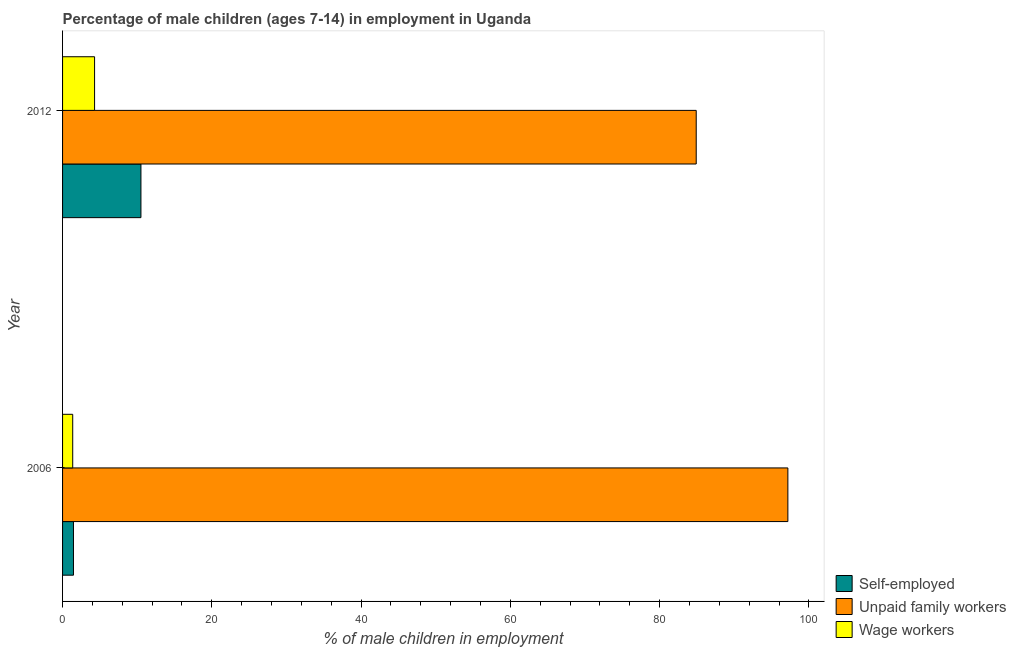Are the number of bars on each tick of the Y-axis equal?
Your answer should be very brief. Yes. What is the label of the 1st group of bars from the top?
Your response must be concise. 2012. What is the percentage of self employed children in 2012?
Your response must be concise. 10.5. Across all years, what is the maximum percentage of children employed as unpaid family workers?
Ensure brevity in your answer.  97.18. Across all years, what is the minimum percentage of self employed children?
Offer a terse response. 1.46. What is the total percentage of children employed as wage workers in the graph?
Make the answer very short. 5.65. What is the difference between the percentage of children employed as unpaid family workers in 2006 and that in 2012?
Offer a very short reply. 12.28. What is the difference between the percentage of self employed children in 2006 and the percentage of children employed as wage workers in 2012?
Give a very brief answer. -2.83. What is the average percentage of children employed as unpaid family workers per year?
Your answer should be compact. 91.04. In the year 2006, what is the difference between the percentage of children employed as wage workers and percentage of children employed as unpaid family workers?
Your response must be concise. -95.82. What is the ratio of the percentage of children employed as unpaid family workers in 2006 to that in 2012?
Provide a succinct answer. 1.15. What does the 1st bar from the top in 2006 represents?
Ensure brevity in your answer.  Wage workers. What does the 3rd bar from the bottom in 2006 represents?
Offer a very short reply. Wage workers. Is it the case that in every year, the sum of the percentage of self employed children and percentage of children employed as unpaid family workers is greater than the percentage of children employed as wage workers?
Provide a short and direct response. Yes. How many bars are there?
Offer a terse response. 6. Are all the bars in the graph horizontal?
Give a very brief answer. Yes. What is the difference between two consecutive major ticks on the X-axis?
Your answer should be very brief. 20. Does the graph contain any zero values?
Your answer should be compact. No. Where does the legend appear in the graph?
Ensure brevity in your answer.  Bottom right. How many legend labels are there?
Make the answer very short. 3. What is the title of the graph?
Ensure brevity in your answer.  Percentage of male children (ages 7-14) in employment in Uganda. Does "Negligence towards kids" appear as one of the legend labels in the graph?
Your answer should be compact. No. What is the label or title of the X-axis?
Give a very brief answer. % of male children in employment. What is the % of male children in employment of Self-employed in 2006?
Provide a succinct answer. 1.46. What is the % of male children in employment in Unpaid family workers in 2006?
Offer a terse response. 97.18. What is the % of male children in employment of Wage workers in 2006?
Provide a short and direct response. 1.36. What is the % of male children in employment of Unpaid family workers in 2012?
Offer a terse response. 84.9. What is the % of male children in employment of Wage workers in 2012?
Your answer should be very brief. 4.29. Across all years, what is the maximum % of male children in employment in Unpaid family workers?
Offer a very short reply. 97.18. Across all years, what is the maximum % of male children in employment of Wage workers?
Provide a succinct answer. 4.29. Across all years, what is the minimum % of male children in employment in Self-employed?
Your answer should be compact. 1.46. Across all years, what is the minimum % of male children in employment in Unpaid family workers?
Give a very brief answer. 84.9. Across all years, what is the minimum % of male children in employment in Wage workers?
Provide a short and direct response. 1.36. What is the total % of male children in employment in Self-employed in the graph?
Your answer should be very brief. 11.96. What is the total % of male children in employment of Unpaid family workers in the graph?
Keep it short and to the point. 182.08. What is the total % of male children in employment in Wage workers in the graph?
Keep it short and to the point. 5.65. What is the difference between the % of male children in employment of Self-employed in 2006 and that in 2012?
Give a very brief answer. -9.04. What is the difference between the % of male children in employment in Unpaid family workers in 2006 and that in 2012?
Offer a terse response. 12.28. What is the difference between the % of male children in employment of Wage workers in 2006 and that in 2012?
Your answer should be compact. -2.93. What is the difference between the % of male children in employment of Self-employed in 2006 and the % of male children in employment of Unpaid family workers in 2012?
Keep it short and to the point. -83.44. What is the difference between the % of male children in employment of Self-employed in 2006 and the % of male children in employment of Wage workers in 2012?
Keep it short and to the point. -2.83. What is the difference between the % of male children in employment of Unpaid family workers in 2006 and the % of male children in employment of Wage workers in 2012?
Ensure brevity in your answer.  92.89. What is the average % of male children in employment in Self-employed per year?
Provide a short and direct response. 5.98. What is the average % of male children in employment of Unpaid family workers per year?
Ensure brevity in your answer.  91.04. What is the average % of male children in employment in Wage workers per year?
Ensure brevity in your answer.  2.83. In the year 2006, what is the difference between the % of male children in employment of Self-employed and % of male children in employment of Unpaid family workers?
Your answer should be compact. -95.72. In the year 2006, what is the difference between the % of male children in employment of Unpaid family workers and % of male children in employment of Wage workers?
Your response must be concise. 95.82. In the year 2012, what is the difference between the % of male children in employment in Self-employed and % of male children in employment in Unpaid family workers?
Give a very brief answer. -74.4. In the year 2012, what is the difference between the % of male children in employment of Self-employed and % of male children in employment of Wage workers?
Provide a succinct answer. 6.21. In the year 2012, what is the difference between the % of male children in employment in Unpaid family workers and % of male children in employment in Wage workers?
Ensure brevity in your answer.  80.61. What is the ratio of the % of male children in employment of Self-employed in 2006 to that in 2012?
Your answer should be very brief. 0.14. What is the ratio of the % of male children in employment of Unpaid family workers in 2006 to that in 2012?
Make the answer very short. 1.14. What is the ratio of the % of male children in employment of Wage workers in 2006 to that in 2012?
Make the answer very short. 0.32. What is the difference between the highest and the second highest % of male children in employment in Self-employed?
Ensure brevity in your answer.  9.04. What is the difference between the highest and the second highest % of male children in employment in Unpaid family workers?
Provide a short and direct response. 12.28. What is the difference between the highest and the second highest % of male children in employment in Wage workers?
Ensure brevity in your answer.  2.93. What is the difference between the highest and the lowest % of male children in employment in Self-employed?
Provide a short and direct response. 9.04. What is the difference between the highest and the lowest % of male children in employment of Unpaid family workers?
Give a very brief answer. 12.28. What is the difference between the highest and the lowest % of male children in employment of Wage workers?
Offer a terse response. 2.93. 